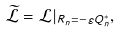Convert formula to latex. <formula><loc_0><loc_0><loc_500><loc_500>\widetilde { \mathcal { L } } = \mathcal { L } | _ { R _ { n } = - \varepsilon Q _ { n } ^ { * } } ,</formula> 